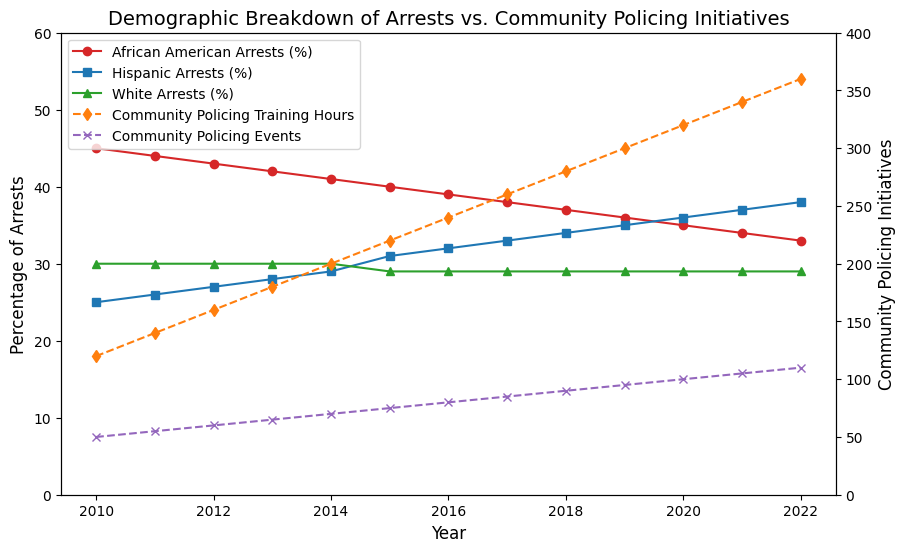what trend do you observe in the percentage of African American arrests from 2010 to 2022? From the figure, we observe that the percentage of African American arrests consistently decreases over the years from 2010 to 2022. The percentage starts at 45% in 2010 and declines each year reaching 33% by 2022.
Answer: Steady decrease which demographic group had stable arrest percentages over the years? Referring to the figure, the percentage of White arrests remains constant at 29% from 2010 to 2022 with a slight dip to 30% between 2010 and 2014, and only a small change to 30% at most years except 2015 when it was 29%.
Answer: White arrests in what year did the percentage of Hispanic arrests surpass that of African American arrests? Observing the figure, we see that in 2020, the percentage of Hispanic arrests (36%) surpasses that of African American arrests (35%).
Answer: 2020 how did community policing training hours change from 2010 to 2022? The figure shows that community policing training hours steadily increased every year from 2010 (120 hours) to 2022 (360 hours).
Answer: Steadily increased compare the trend of community policing events with the percentage of arrests for Hispanic individuals. The figure shows that as the community policing events increase each year from 50 in 2010 to 110 in 2022, the percentage of arrests for Hispanic individuals also increases from 25% to 38%.
Answer: Both increase what visual indicators differentiate between community policing training hours and community policing events? Community policing training hours are represented by orange diamond-dashed lines, whereas community policing events are depicted by purple x-dashed lines, making it clear which line corresponds to which initiative.
Answer: Different colored and shaped dashed lines what is the difference in percentage points between African American arrests and Hispanic arrests in 2015? In 2015, the percentage of African American arrests is 40%, and for Hispanic arrests, it is 31%. The difference between them is 40% - 31% = 9%.
Answer: 9 percentage points what was the average percentage of White arrests from 2010 to 2022? The percentage of White arrests remains steady at 30% from 2010 to 2014 and then 29% from 2015 to 2022. Calculating the average: (30*5 + 29*8) / 13 = (150+232) / 13 = 29.23.
Answer: 29.23% which year shows the highest number of community policing events, and what are the percentages of arrests for the three demographic groups in that year? The highest number of community policing events occurs in 2022 with 110 events. The percentages of arrests are: African American (33%), Hispanic (38%), and White (29%).
Answer: 2022; 33%, 38%, 29% how is the relationship between community policing training hours and the percentage of African American arrests from 2010 to 2022? The figure shows that as the community policing training hours increase from 120 in 2010 to 360 in 2022, the percentage of African American arrests decreases from 45% to 33%.
Answer: Inversely related 